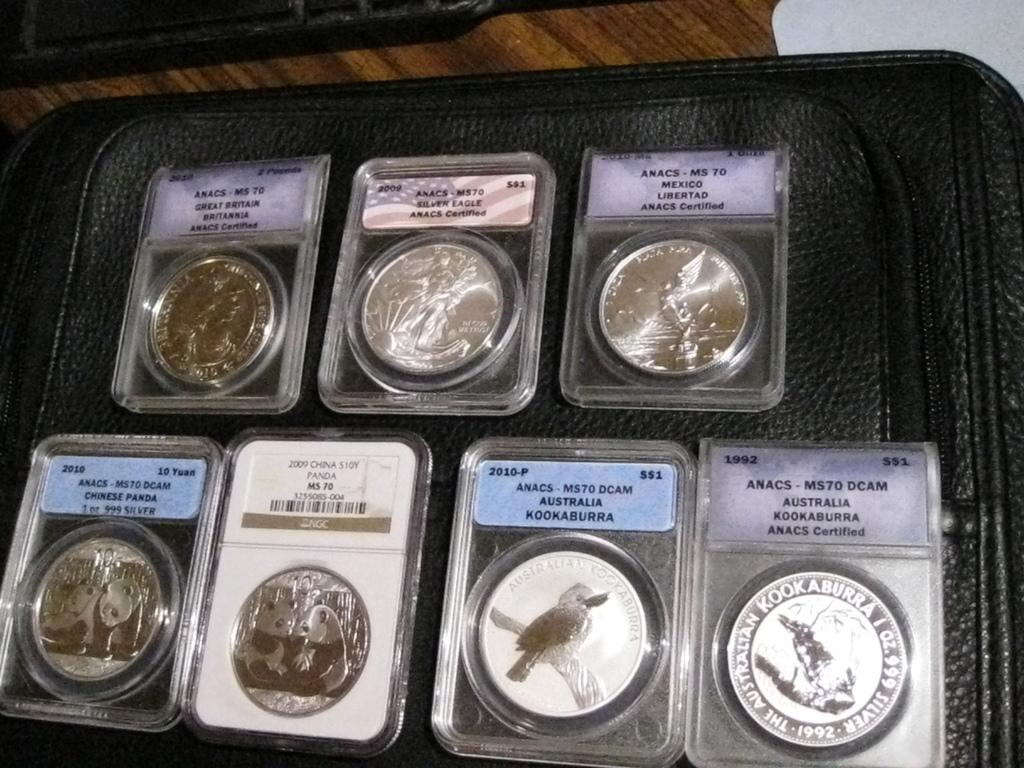<image>
Create a compact narrative representing the image presented. Coins on display include ANACS - MS70 and a Chine S10Y. 